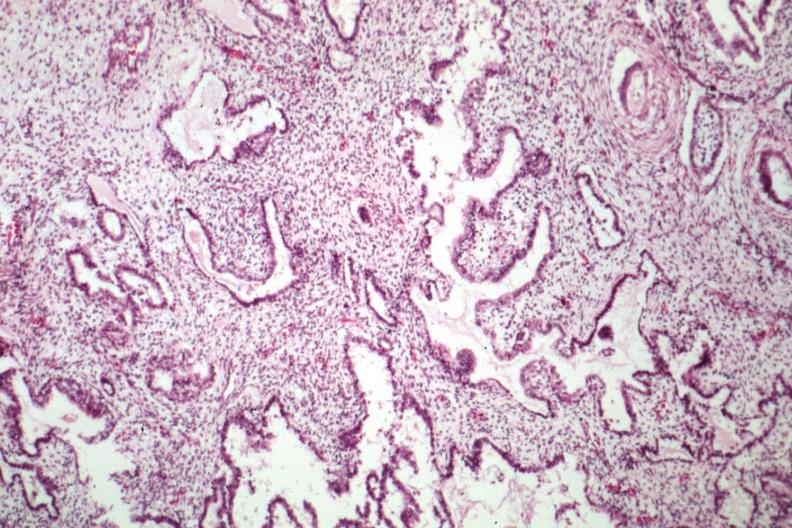does newborn cord around neck show epithelial component resembling endometrium?
Answer the question using a single word or phrase. No 